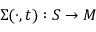Convert formula to latex. <formula><loc_0><loc_0><loc_500><loc_500>\Sigma ( \cdot , t ) \colon S \to M</formula> 